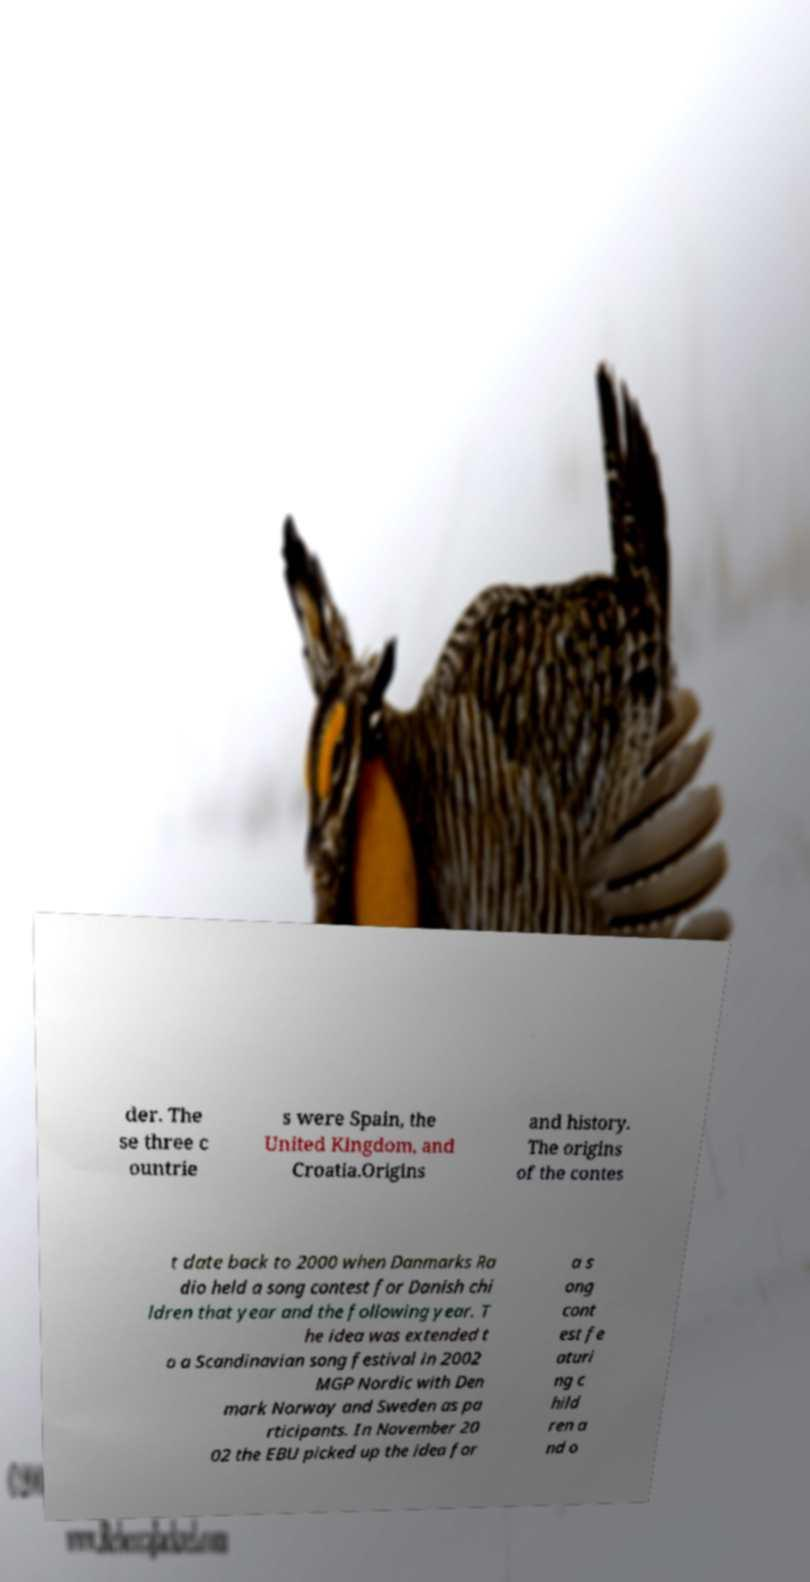Please identify and transcribe the text found in this image. der. The se three c ountrie s were Spain, the United Kingdom, and Croatia.Origins and history. The origins of the contes t date back to 2000 when Danmarks Ra dio held a song contest for Danish chi ldren that year and the following year. T he idea was extended t o a Scandinavian song festival in 2002 MGP Nordic with Den mark Norway and Sweden as pa rticipants. In November 20 02 the EBU picked up the idea for a s ong cont est fe aturi ng c hild ren a nd o 